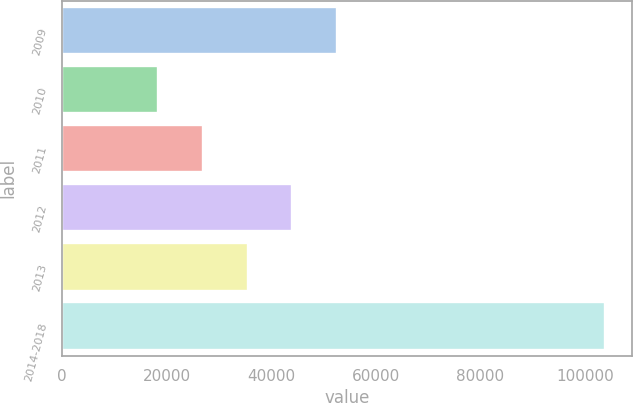Convert chart. <chart><loc_0><loc_0><loc_500><loc_500><bar_chart><fcel>2009<fcel>2010<fcel>2011<fcel>2012<fcel>2013<fcel>2014-2018<nl><fcel>52605.2<fcel>18398<fcel>26949.8<fcel>44053.4<fcel>35501.6<fcel>103916<nl></chart> 